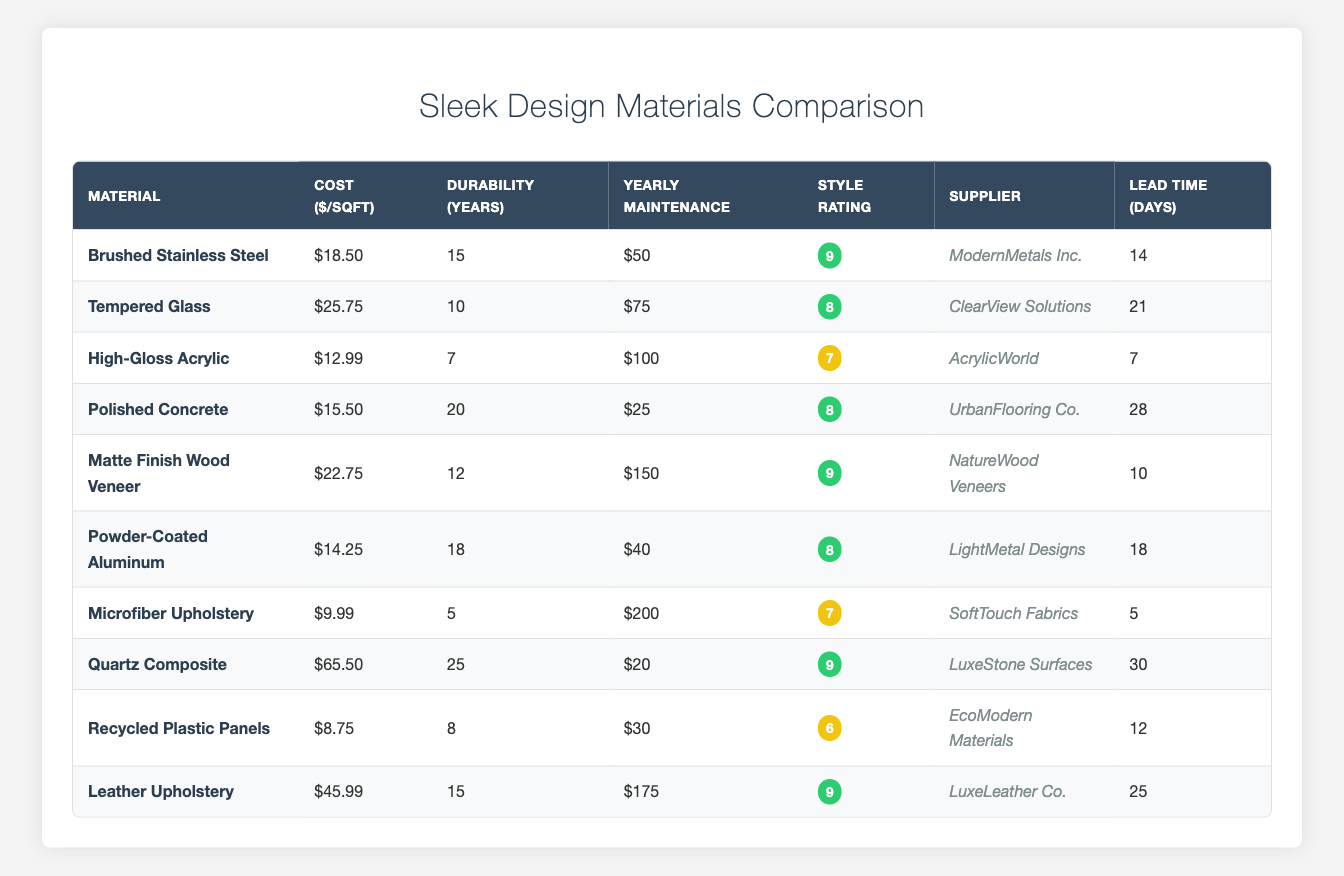What is the cost per square foot of Quartz Composite? The cost per square foot of Quartz Composite is found directly in the table under the "Cost ($/sqft)" column corresponding to the "Material" row for Quartz Composite. The value listed is 65.50.
Answer: 65.50 Which material has the longest durability? To find the material with the longest durability, we look through the "Durability (years)" column and identify the highest value. Quartz Composite has 25 years, which is greater than any other material listed in the table.
Answer: Quartz Composite What is the average yearly maintenance cost of all the materials? To calculate the average, sum the maintenance costs from the "Yearly Maintenance" column: 50 + 75 + 100 + 25 + 150 + 40 + 200 + 20 + 30 + 175 = 865. There are 10 materials, so we divide 865 by 10, resulting in 86.5.
Answer: 86.5 True or False: High-Gloss Acrylic has a higher durability than Tempered Glass. In the table, High-Gloss Acrylic is listed with a durability of 7 years and Tempered Glass with a durability of 10 years. Since 7 is less than 10, the statement is false.
Answer: False Which material has the lowest cost per square foot and what is that cost? Looking through the "Cost ($/sqft)" column, Recycled Plastic Panels has the lowest cost at 8.75. This is less than the costs of all other materials listed.
Answer: 8.75 Which supplier provides Brushed Stainless Steel and what is its style rating? In the table under "Supplier," we find that Brushed Stainless Steel is supplied by ModernMetals Inc. The corresponding style rating is found in the "Style Rating" column, which shows a value of 9.
Answer: ModernMetals Inc.; 9 What is the total durability of materials that have a style rating of 9? To find the total durability, we filter the materials with a style rating of 9: Brushed Stainless Steel (15), Matte Finish Wood Veneer (12), Quartz Composite (25), and Leather Upholstery (15). Adding these gives: 15 + 12 + 25 + 15 = 67.
Answer: 67 Which material has the highest style rating and what is its yearly maintenance cost? The highest style rating in the table is 9, associated with Brushed Stainless Steel, Matte Finish Wood Veneer, Quartz Composite, and Leather Upholstery. Out of these, Leather Upholstery has a highest yearly maintenance cost of 175.
Answer: 175 